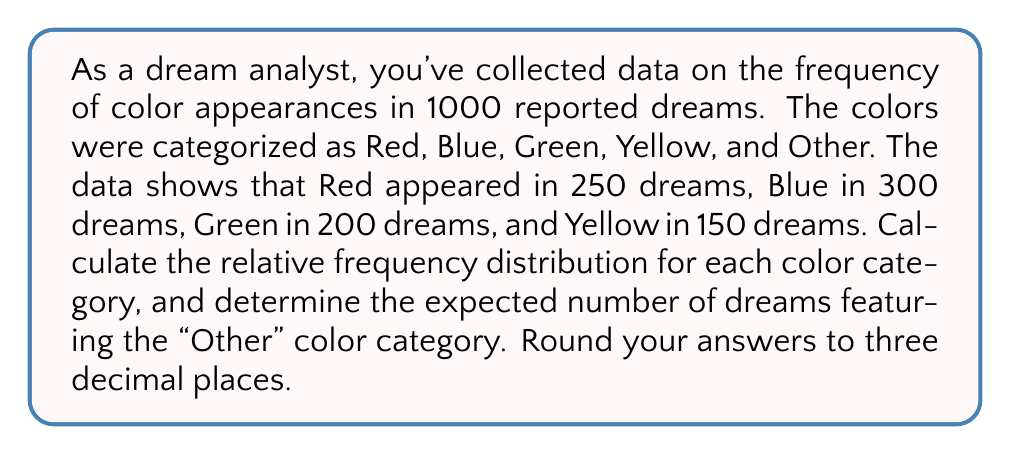Give your solution to this math problem. To solve this problem, we need to follow these steps:

1. Calculate the total number of dreams with known color categories:
   $250 + 300 + 200 + 150 = 900$ dreams

2. Calculate the number of dreams in the "Other" category:
   $1000 - 900 = 100$ dreams

3. Calculate the relative frequency for each color category:
   Relative frequency = Number of dreams with the color / Total number of dreams

   Red: $f_{Red} = \frac{250}{1000} = 0.250$
   Blue: $f_{Blue} = \frac{300}{1000} = 0.300$
   Green: $f_{Green} = \frac{200}{1000} = 0.200$
   Yellow: $f_{Yellow} = \frac{150}{1000} = 0.150$
   Other: $f_{Other} = \frac{100}{1000} = 0.100$

4. Verify that the sum of all relative frequencies equals 1:
   $0.250 + 0.300 + 0.200 + 0.150 + 0.100 = 1.000$

5. The expected number of dreams featuring the "Other" color category is already calculated in step 2: 100 dreams

Thus, the relative frequency distribution for each color category (rounded to three decimal places) is:
Red: 0.250
Blue: 0.300
Green: 0.200
Yellow: 0.150
Other: 0.100

And the expected number of dreams featuring the "Other" color category is 100.
Answer: Relative frequency distribution:
Red: 0.250
Blue: 0.300
Green: 0.200
Yellow: 0.150
Other: 0.100

Expected number of dreams featuring the "Other" color category: 100 